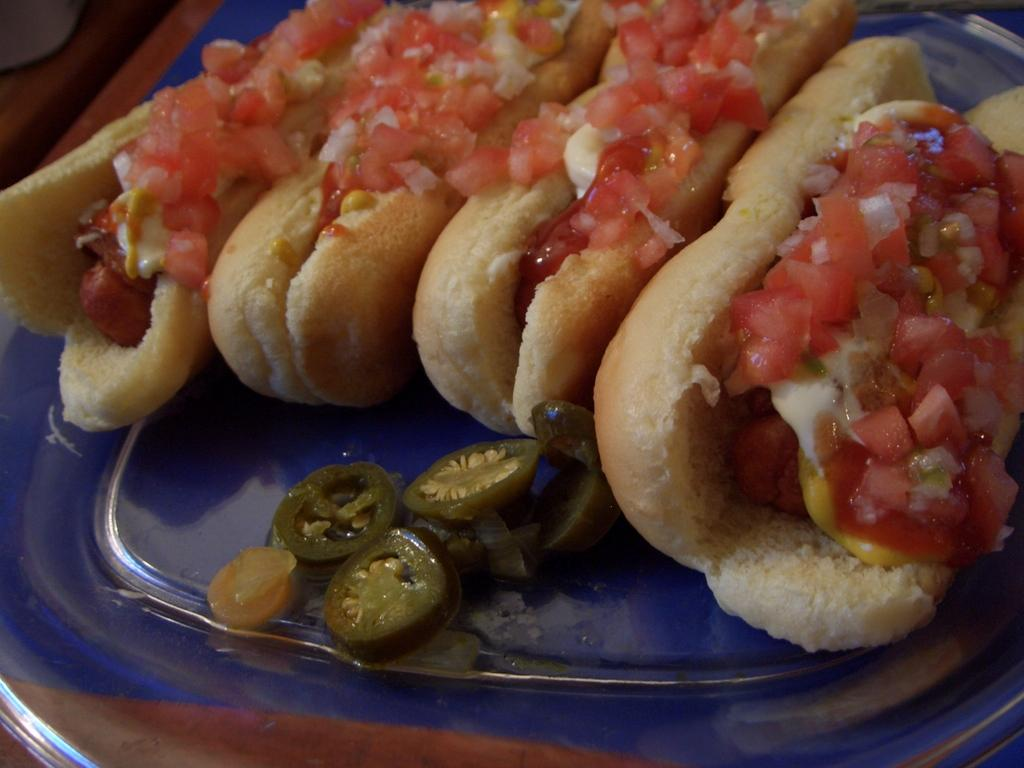What piece of furniture is present in the image? There is a table in the image. What is placed on the table? There is a plate on the table. What can be found on the plate? There is a food item on the plate. How many boots can be seen in the hole on the plate? There are no boots or holes present on the plate in the image. 